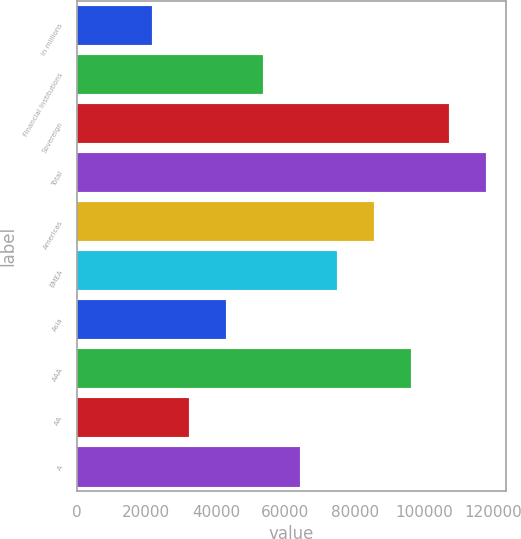Convert chart to OTSL. <chart><loc_0><loc_0><loc_500><loc_500><bar_chart><fcel>in millions<fcel>Financial Institutions<fcel>Sovereign<fcel>Total<fcel>Americas<fcel>EMEA<fcel>Asia<fcel>AAA<fcel>AA<fcel>A<nl><fcel>21467.6<fcel>53567<fcel>107066<fcel>117766<fcel>85666.4<fcel>74966.6<fcel>42867.2<fcel>96366.2<fcel>32167.4<fcel>64266.8<nl></chart> 